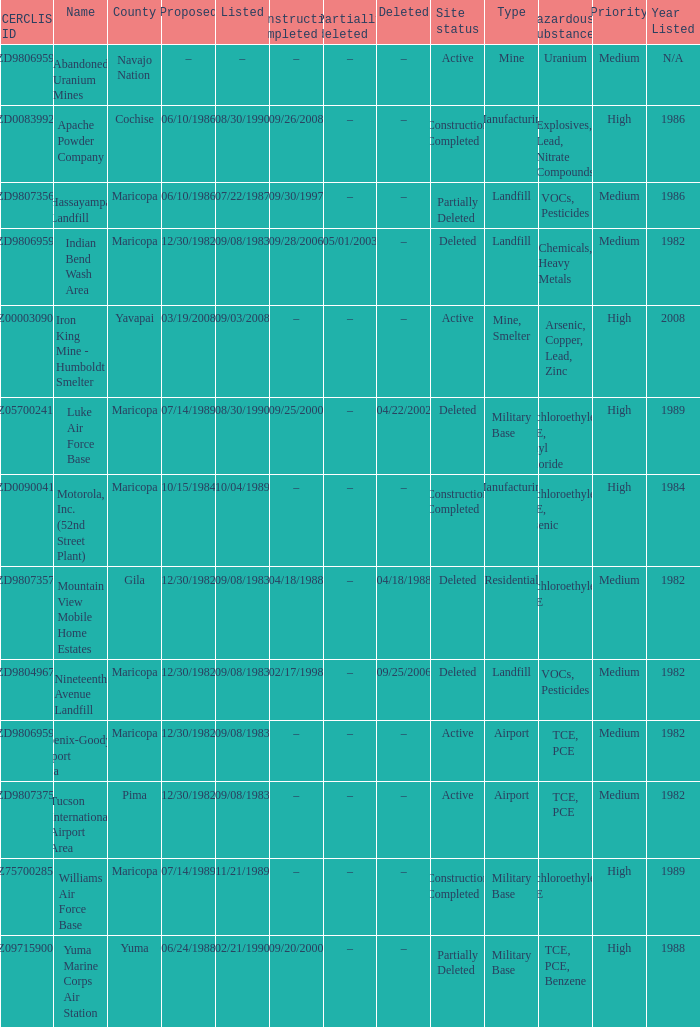What is the cerclis id when the site was proposed on 12/30/1982 and was partially deleted on 05/01/2003? AZD980695969. 